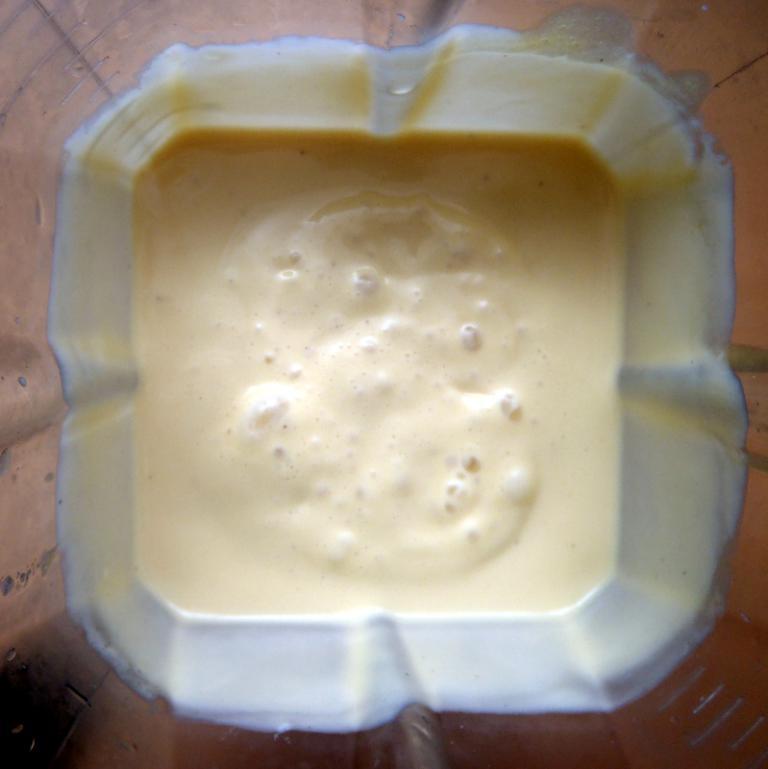Please provide a concise description of this image. In this image we can see a smoothie in a tumbler. 